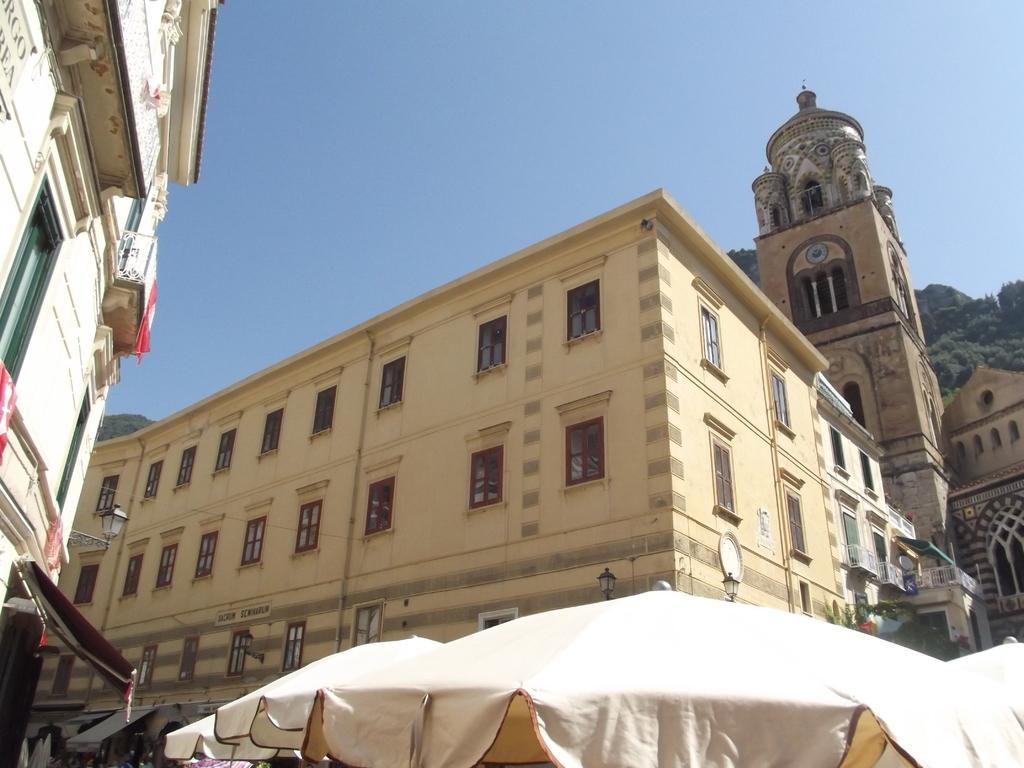What type of structures are present in the image? There are buildings with windows in the image. What objects can be seen at the bottom of the image? Umbrellas are visible at the bottom of the image. What type of vegetation is in the background of the image? There are trees in the background of the image. What is visible in the background of the image besides the trees? The sky is visible in the background of the image. What type of whip is being used to create lace patterns in the image? There is no whip or lace present in the image; it features buildings, umbrellas, trees, and the sky. What is the interest rate for the loan depicted in the image? There is no loan or interest rate mentioned or depicted in the image. 